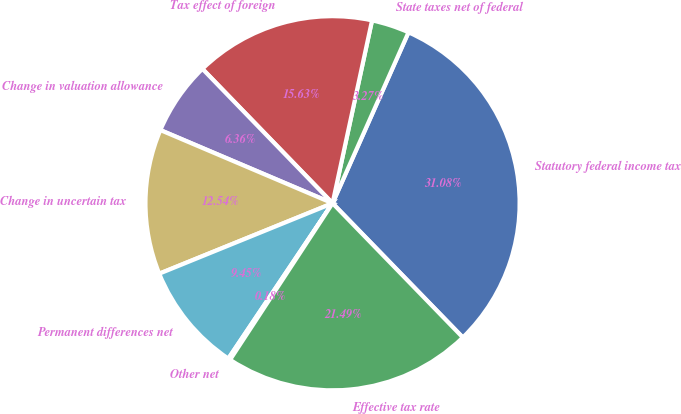<chart> <loc_0><loc_0><loc_500><loc_500><pie_chart><fcel>Statutory federal income tax<fcel>State taxes net of federal<fcel>Tax effect of foreign<fcel>Change in valuation allowance<fcel>Change in uncertain tax<fcel>Permanent differences net<fcel>Other net<fcel>Effective tax rate<nl><fcel>31.08%<fcel>3.27%<fcel>15.63%<fcel>6.36%<fcel>12.54%<fcel>9.45%<fcel>0.18%<fcel>21.49%<nl></chart> 